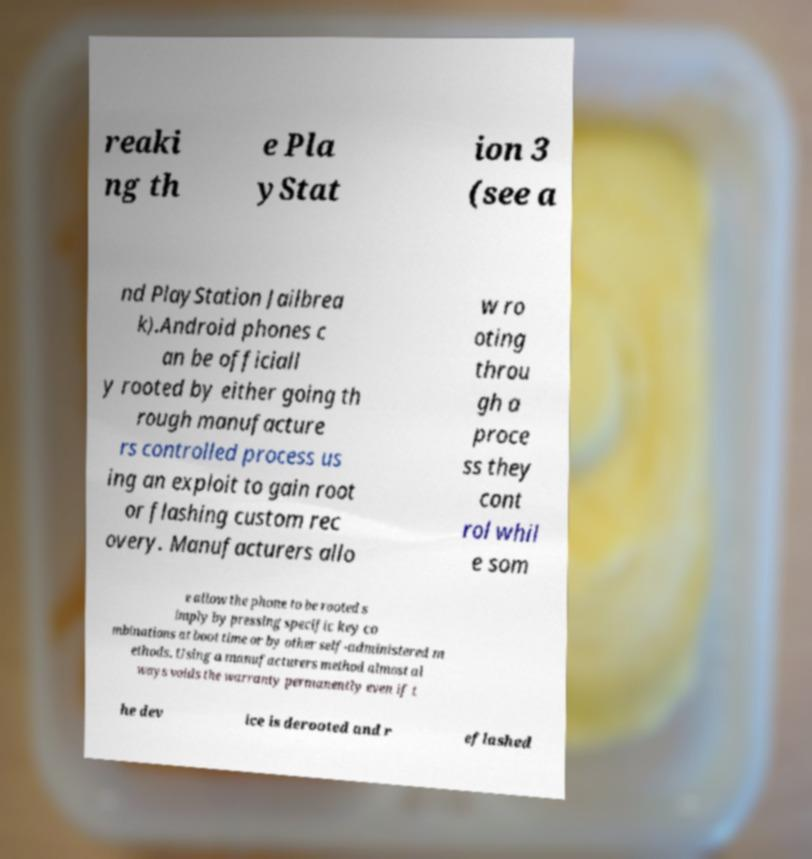Could you assist in decoding the text presented in this image and type it out clearly? reaki ng th e Pla yStat ion 3 (see a nd PlayStation Jailbrea k).Android phones c an be officiall y rooted by either going th rough manufacture rs controlled process us ing an exploit to gain root or flashing custom rec overy. Manufacturers allo w ro oting throu gh a proce ss they cont rol whil e som e allow the phone to be rooted s imply by pressing specific key co mbinations at boot time or by other self-administered m ethods. Using a manufacturers method almost al ways voids the warranty permanently even if t he dev ice is derooted and r eflashed 